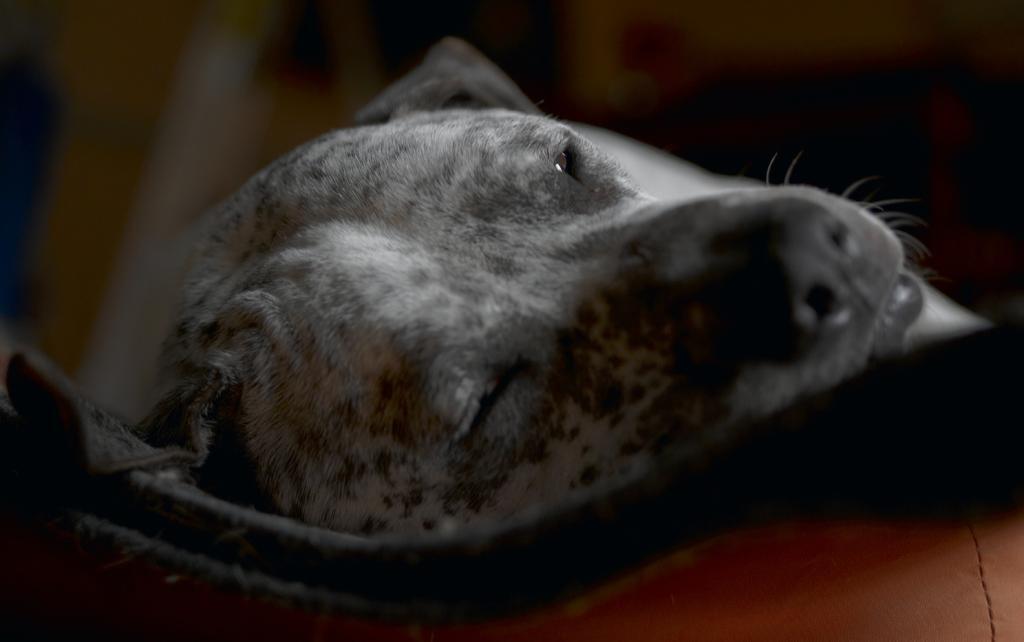Please provide a concise description of this image. In the image there is a black dog laying on carpet on the sofa. 